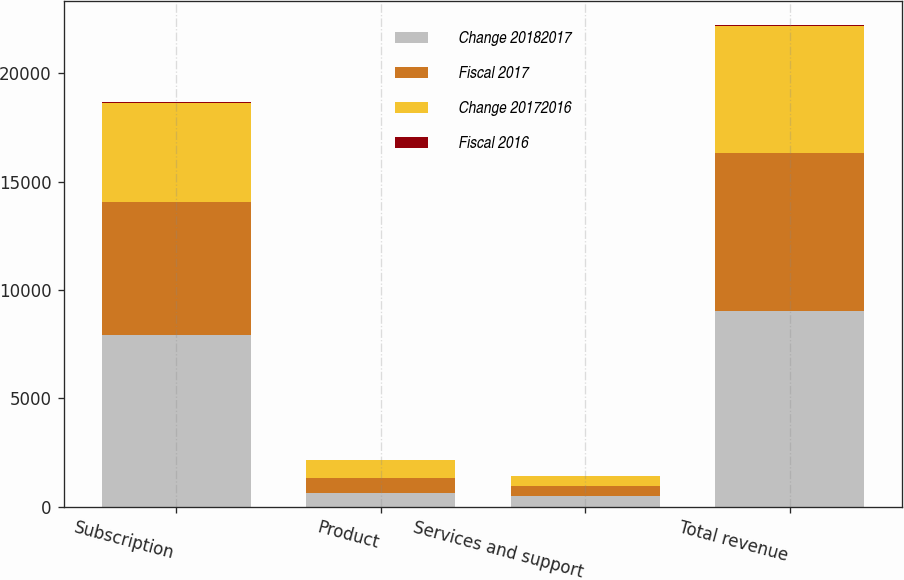Convert chart to OTSL. <chart><loc_0><loc_0><loc_500><loc_500><stacked_bar_chart><ecel><fcel>Subscription<fcel>Product<fcel>Services and support<fcel>Total revenue<nl><fcel>Change 20182017<fcel>7922.2<fcel>622.1<fcel>485.7<fcel>9030<nl><fcel>Fiscal 2017<fcel>6133.9<fcel>706.7<fcel>460.9<fcel>7301.5<nl><fcel>Change 20172016<fcel>4584.8<fcel>800.5<fcel>469.1<fcel>5854.4<nl><fcel>Fiscal 2016<fcel>29<fcel>12<fcel>5<fcel>24<nl></chart> 